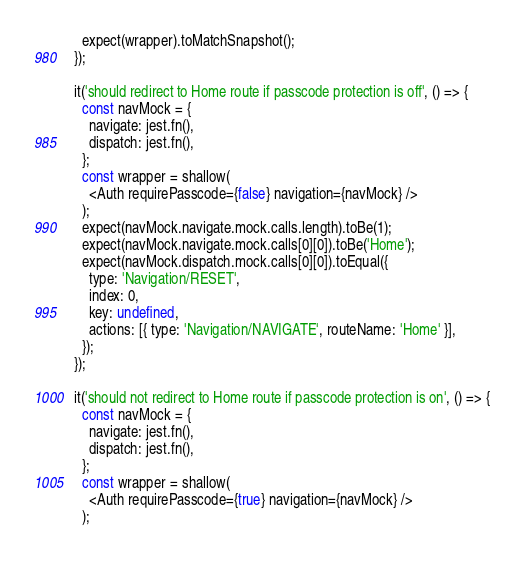<code> <loc_0><loc_0><loc_500><loc_500><_JavaScript_>    expect(wrapper).toMatchSnapshot();
  });

  it('should redirect to Home route if passcode protection is off', () => {
    const navMock = {
      navigate: jest.fn(),
      dispatch: jest.fn(),
    };
    const wrapper = shallow(
      <Auth requirePasscode={false} navigation={navMock} />
    );
    expect(navMock.navigate.mock.calls.length).toBe(1);
    expect(navMock.navigate.mock.calls[0][0]).toBe('Home');
    expect(navMock.dispatch.mock.calls[0][0]).toEqual({
      type: 'Navigation/RESET',
      index: 0,
      key: undefined,
      actions: [{ type: 'Navigation/NAVIGATE', routeName: 'Home' }],
    });
  });

  it('should not redirect to Home route if passcode protection is on', () => {
    const navMock = {
      navigate: jest.fn(),
      dispatch: jest.fn(),
    };
    const wrapper = shallow(
      <Auth requirePasscode={true} navigation={navMock} />
    );</code> 